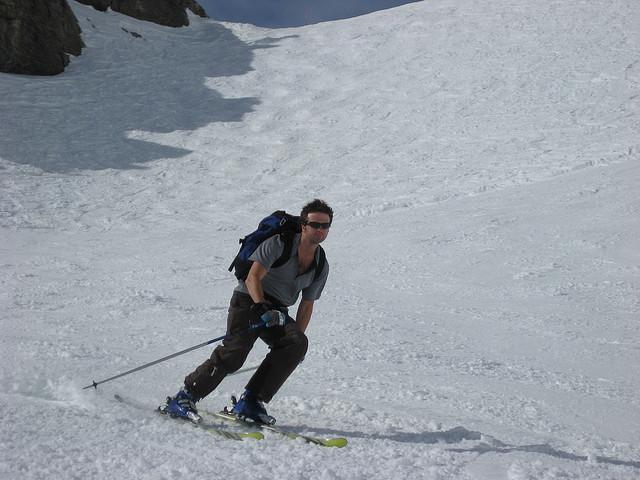What protective gear should the man wear? Please explain your reasoning. helmet. He should have something on his head in case he falls. 